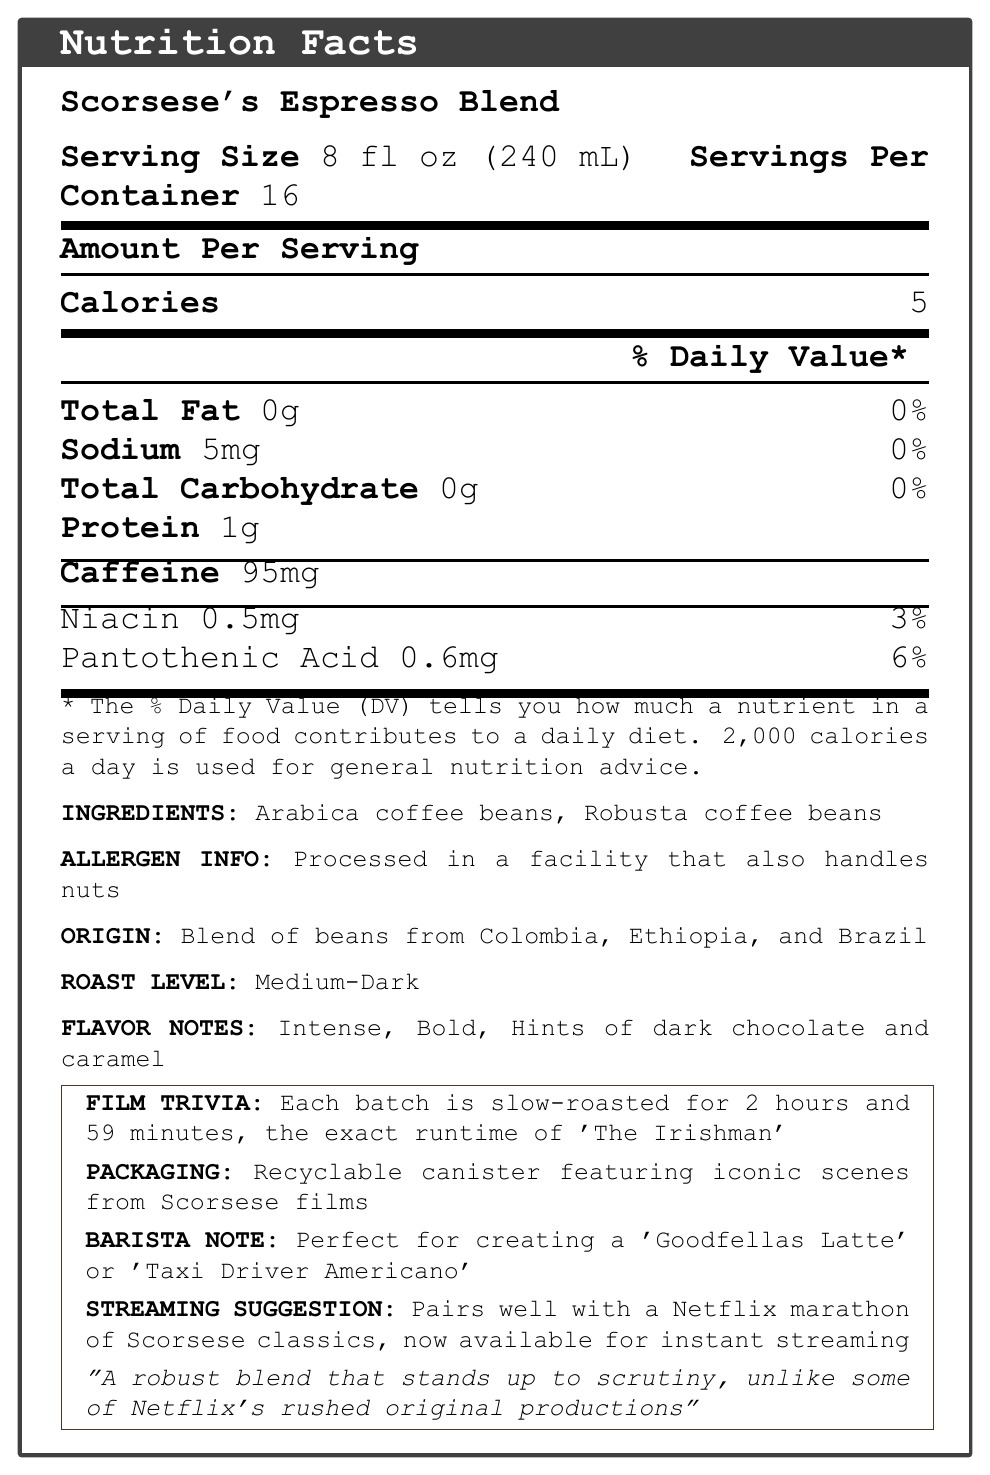what is the serving size of Scorsese's Espresso Blend? The serving size is explicitly stated in the document as "8 fl oz (240 mL)".
Answer: 8 fl oz (240 mL) how many servings are there per container? The document mentions that there are 16 servings per container.
Answer: 16 what is the total calorie count per serving? The document lists the calorie count per serving as "5".
Answer: 5 how much caffeine does each serving contain? According to the document, each serving contains 95mg of caffeine.
Answer: 95mg what is the amount of protein per serving? The document states that each serving has 1g of protein.
Answer: 1g which ingredient is present in the coffee blend? A. Arabica coffee beans B. Sugar C. Milk D. Honey The document identifies "Arabica coffee beans" as one of the ingredients.
Answer: A. Arabica coffee beans how long is each batch of Scorsese's Espresso Blend roasted for? A. 1 hour B. 1.5 hours C. 2 hours and 59 minutes D. 3 hours The document notes that each batch is slow-roasted for 2 hours and 59 minutes to match the runtime of 'The Irishman'.
Answer: C. 2 hours and 59 minutes does Scorsese's Espresso Blend contain any fat? The document specifies that the total fat per serving is 0g, which implies it contains no fat.
Answer: No is the packaging of Scorsese's Espresso Blend recyclable? The document mentions that the canister packaging is recyclable.
Answer: Yes summarize the main information presented on the document. This summary includes all key points regarding the nutritional information, ingredients, allergens, origin, roast level, flavor notes, packaging, and suggested pairing mentioned in the document.
Answer: Scorsese's Espresso Blend is a specialty coffee with a serving size of 8 fl oz, containing 5 calories, 0g fat, 5mg sodium, 0g carbohydrates, 1g protein, and 95mg caffeine per serving. It includes niacin and pantothenic acid. The ingredients are Arabica and Robusta coffee beans, processed in a facility that handles nuts. It is a medium-dark roast with flavor notes of dark chocolate and caramel. The packaging is recyclable and features iconic scenes from Scorsese films. The blend is slow-roasted for 2 hours and 59 minutes and suggested for enjoying during a Netflix marathon of Scorsese classics. what is the daily value percentage of sodium per serving? The document lists the daily value percentage for sodium as 0%.
Answer: 0% what are the flavor notes of the coffee blend? The document describes the flavor notes as "Intense, Bold, Hints of dark chocolate and caramel".
Answer: Intense, Bold, Hints of dark chocolate and caramel where are the coffee beans in the blend sourced from? The document mentions that the coffee beans are a blend from Colombia, Ethiopia, and Brazil.
Answer: Colombia, Ethiopia, and Brazil which mineral listed contributes 6% to the daily value per serving? The document lists Pantothenic Acid as contributing 6% to the daily value.
Answer: Pantothenic Acid what is the recommended film activity to pair with drinking this coffee? The document recommends pairing the coffee with "a Netflix marathon of Scorsese classics, now available for instant streaming".
Answer: A Netflix marathon of Scorsese classics how does the critic compare the coffee blend to Netflix's original productions? The document includes the critic's quote: "A robust blend that stands up to scrutiny, unlike some of Netflix's rushed original productions."
Answer: A robust blend that stands up to scrutiny, unlike some of Netflix's rushed original productions what type of facility processes this coffee? The document states that the coffee is processed in a facility that also handles nuts.
Answer: Processed in a facility that also handles nuts what is the amount of total carbohydrates per serving? The document lists the total carbohydrate content per serving as 0g.
Answer: 0g how does the coffee blend describe its roast level? The document describes the roast level as "Medium-Dark".
Answer: Medium-Dark list all vitamins and minerals mentioned in the document. The document mentions Niacin and Pantothenic Acid as vitamins and minerals included.
Answer: Niacin and Pantothenic Acid does the document specify the price of the coffee blend? The document does not provide any information about the price of the coffee blend.
Answer: Not enough information 